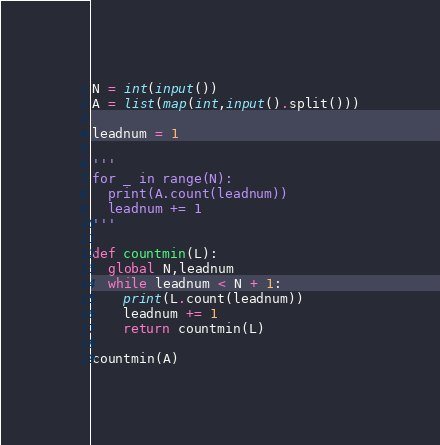<code> <loc_0><loc_0><loc_500><loc_500><_Python_>N = int(input())
A = list(map(int,input().split()))

leadnum = 1

'''
for _ in range(N):
  print(A.count(leadnum))
  leadnum += 1
'''

def countmin(L):
  global N,leadnum
  while leadnum < N + 1:
    print(L.count(leadnum))
    leadnum += 1
    return countmin(L)

countmin(A)</code> 